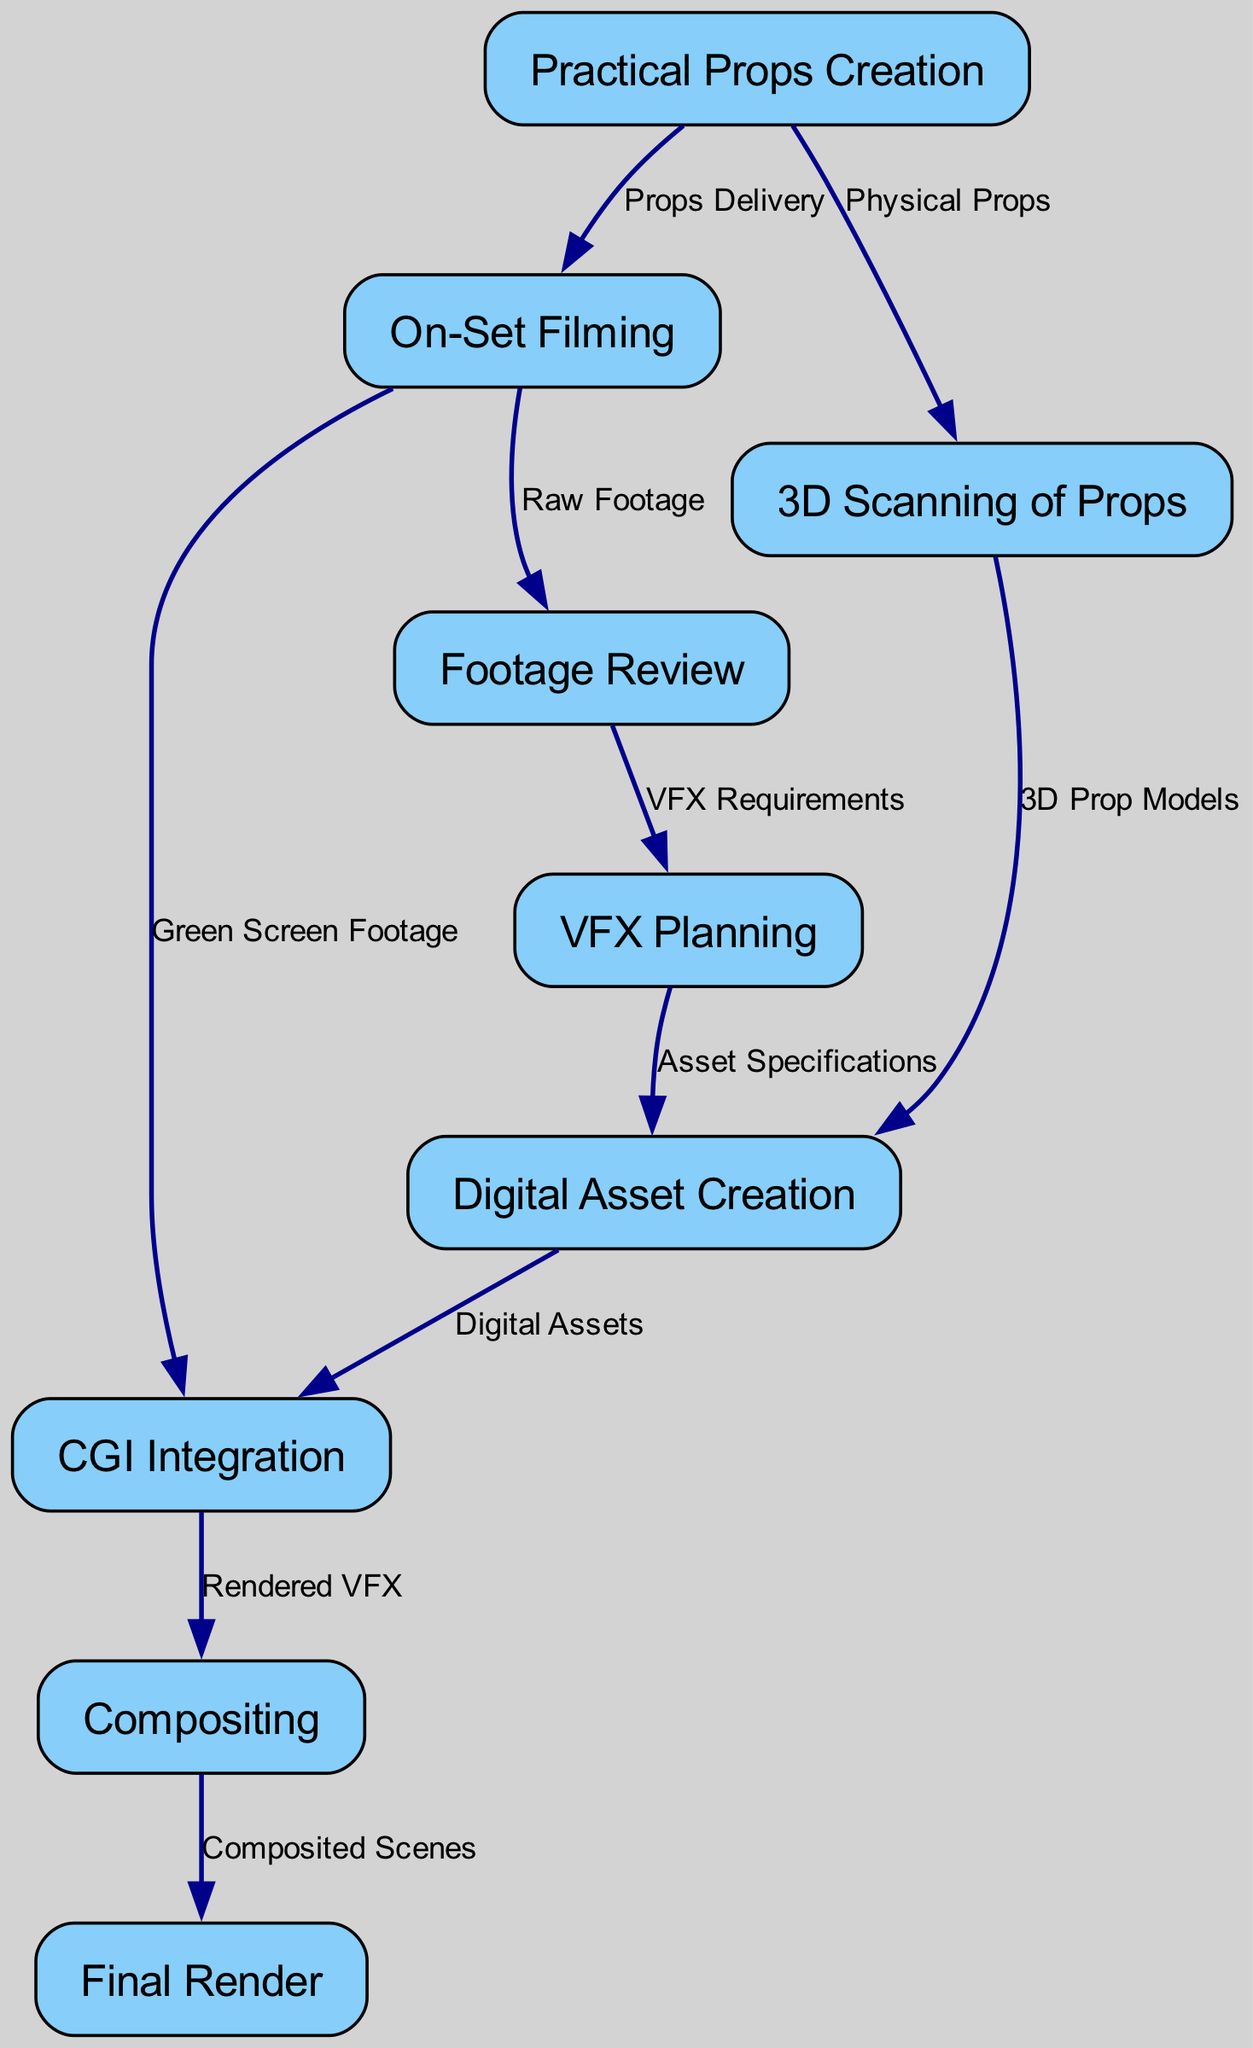What are the total number of nodes in the diagram? The diagram contains a set of distinct entities or stages that are represented as nodes. By counting each unique node listed in the "nodes" section, we find there are nine nodes in total.
Answer: 9 What is the relationship between 'On-Set Filming' and 'Footage Review'? The diagram shows a directed edge from 'On-Set Filming' to 'Footage Review' labeled "Raw Footage," indicating that the output from the filming stage provides the raw footage for review.
Answer: Raw Footage What follows 'Footage Review' in the diagram? By examining the diagram, we see an arrow directed from 'Footage Review' to 'VFX Planning,' indicating that the next stage after reviewing the footage is to plan the visual effects.
Answer: VFX Planning Which node receives edges from both 'Practical Props Creation' and 'VFX Planning'? The diagram displays edges from 'Practical Props Creation' and 'VFX Planning' that both connect to 'Digital Asset Creation.' This indicates that both practical props and planning contribute to digital asset creation.
Answer: Digital Asset Creation How many edges connect to the 'CGI Integration' node? Looking at the diagram, we can see that 'CGI Integration' has edges coming from 'Digital Asset Creation' and 'Green Screen Footage.' By counting these connections, we find there are two edges.
Answer: 2 What is the direct output of the 'Compositing' stage? The directed edge from 'Compositing' clearly points to 'Final Render,' indicating that the output of the compositing stage is the final render of the integrated visual effects.
Answer: Final Render What is the primary purpose of the '3D Scanning of Props' node? In the diagram, '3D Scanning of Props' is connected to 'Digital Asset Creation' and is indicated as creating '3D Prop Models' from the physical props. Its primary purpose is to create 3D representations of the props.
Answer: 3D Prop Models What transition is represented by the edge labeled "Props Delivery"? The edge labeled "Props Delivery" shows a transition in the flow from 'Practical Props Creation' to 'On-Set Filming,' signifying the delivery of props to the filming location.
Answer: On-Set Filming How does 'Digital Asset Creation' influence 'CGI Integration'? The diagram shows that 'Digital Asset Creation' outputs 'Digital Assets,' which are necessary for 'CGI Integration.' This flow indicates that the creation of digital assets is a prerequisite for integrating CGI into the footage.
Answer: Digital Assets 